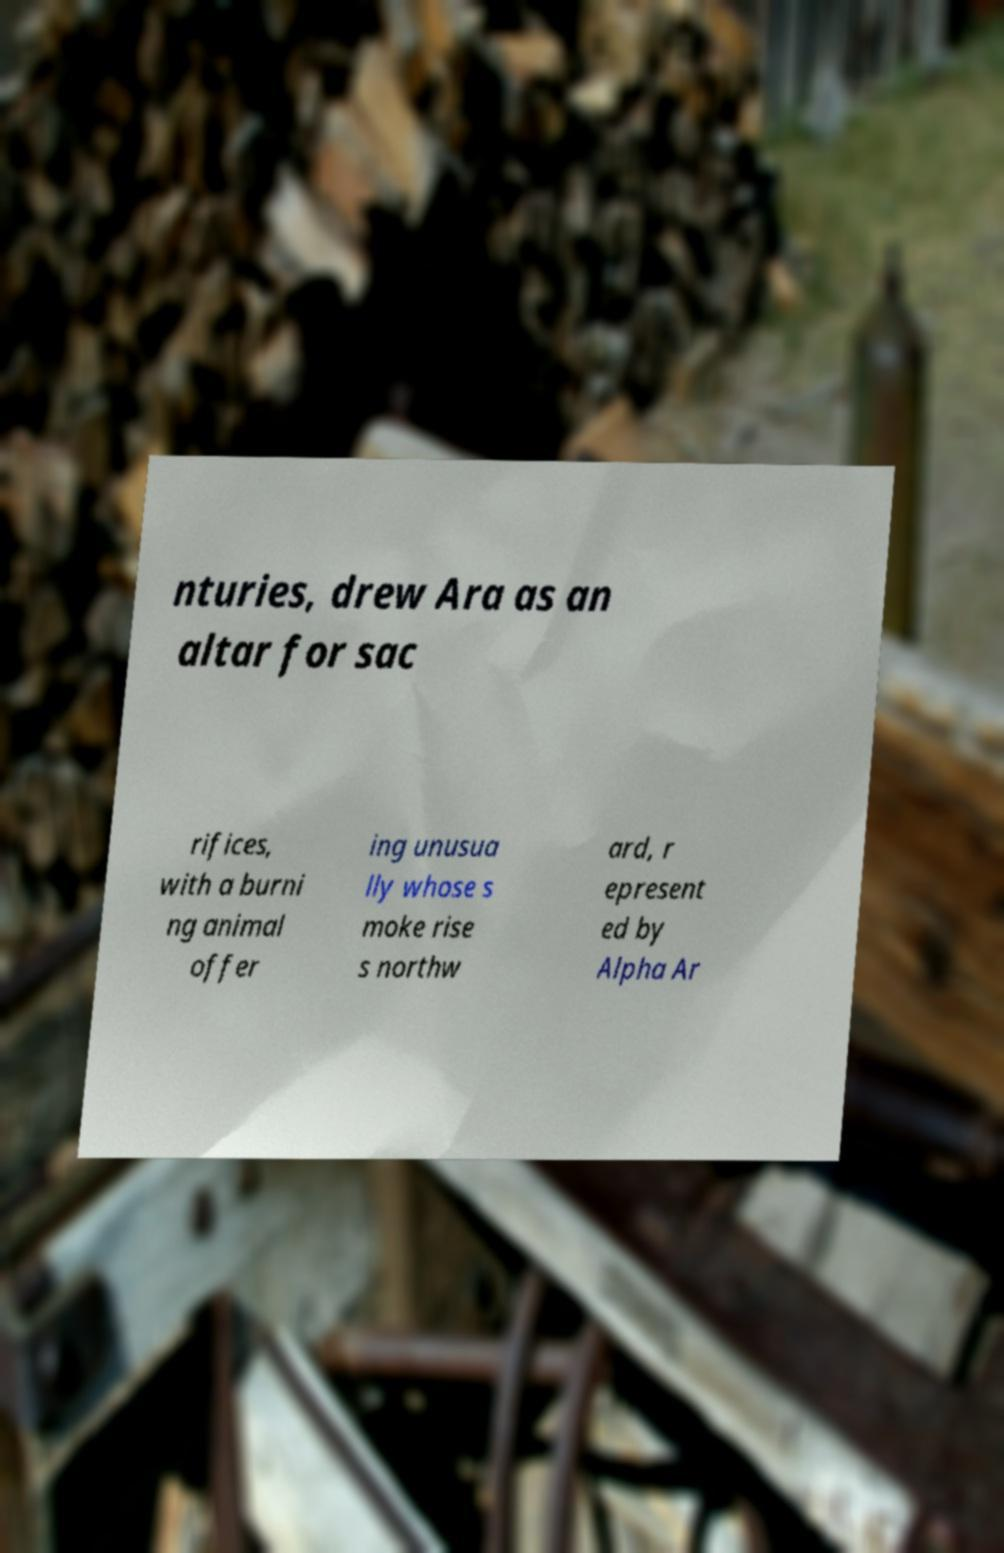Can you accurately transcribe the text from the provided image for me? nturies, drew Ara as an altar for sac rifices, with a burni ng animal offer ing unusua lly whose s moke rise s northw ard, r epresent ed by Alpha Ar 